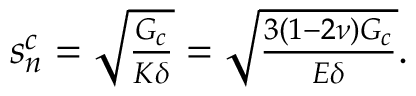<formula> <loc_0><loc_0><loc_500><loc_500>\begin{array} { r } { s _ { n } ^ { c } = \sqrt { \frac { G _ { c } } { K \delta } } = \sqrt { \frac { 3 ( 1 - 2 \nu ) G _ { c } } { E \delta } } . } \end{array}</formula> 